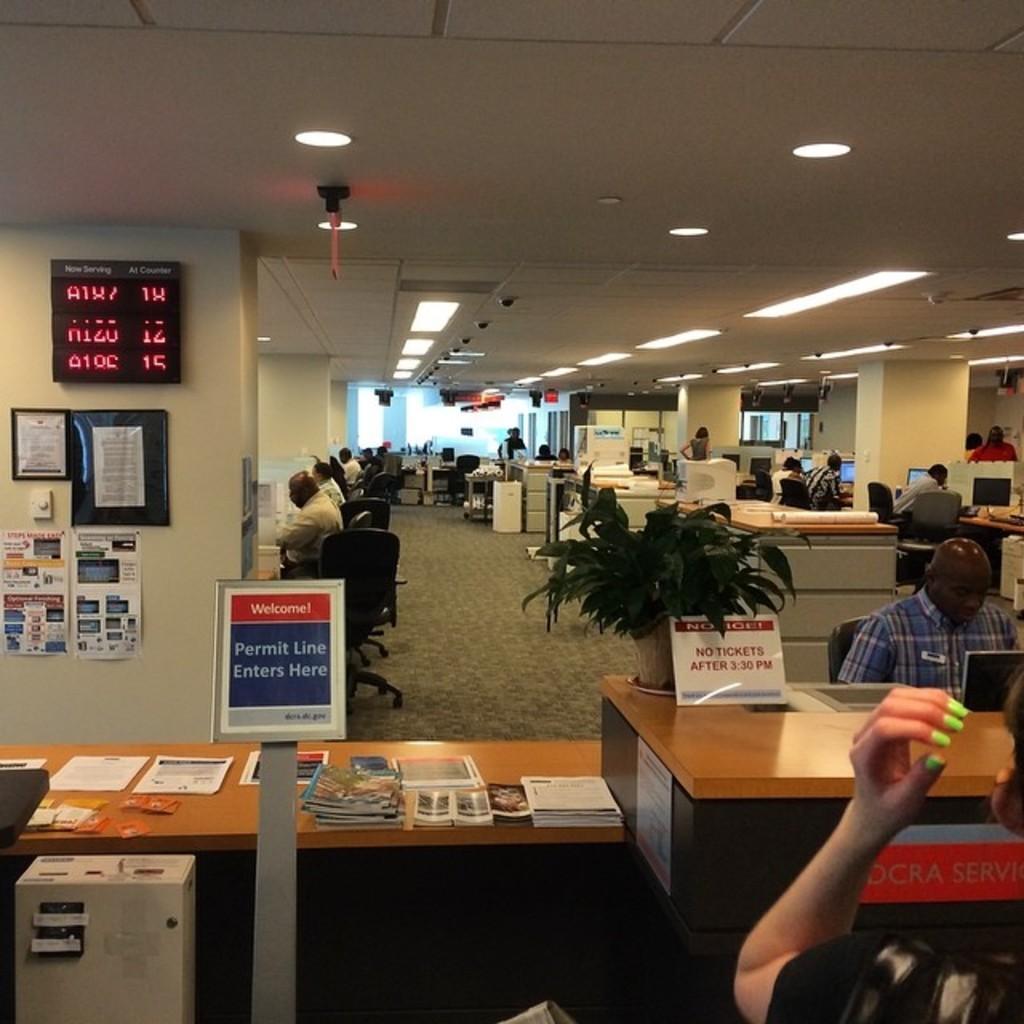In one or two sentences, can you explain what this image depicts? In this picture there are group of people who are sitting on the chair. There is a paper, books on the table. There is a flower pot. There is a laptop. There are few posters on the wall. There is a light. There is a computer and a device. 